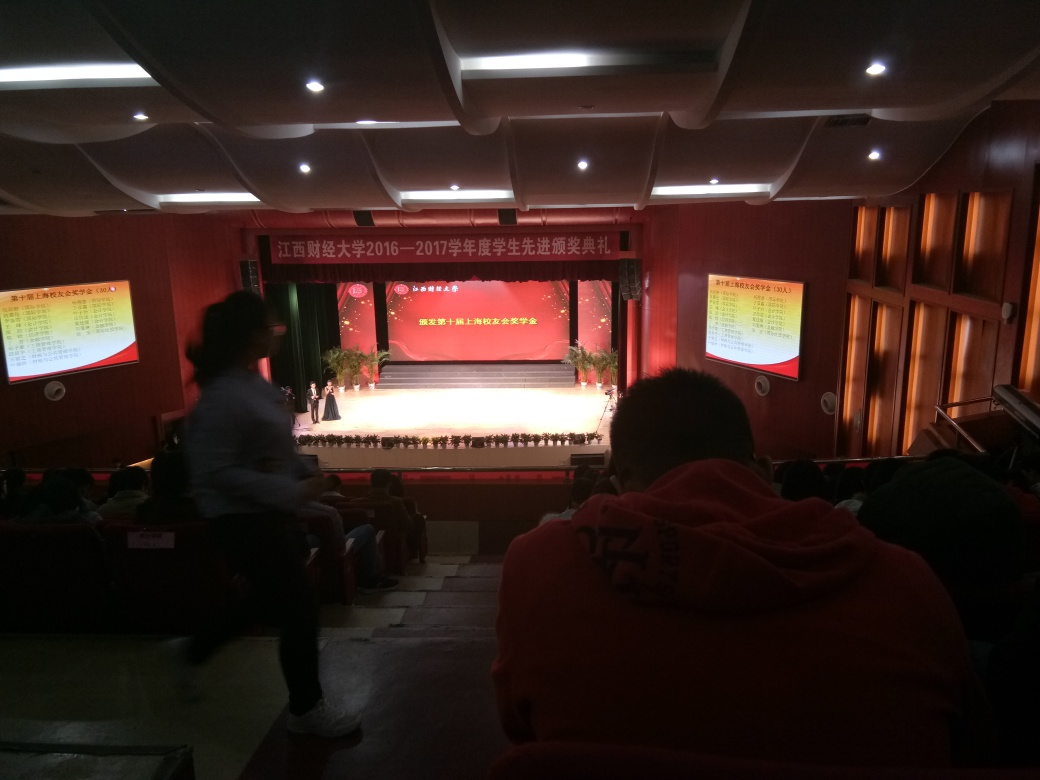What can you infer about the event from the banners and the stage setup? The banners on the left and right feature Chinese text, suggesting that the event is likely taking place in a Chinese-speaking region. Coupled with the organized rows of individuals on the stage and the formal dress code, it could be an educational or academic event, perhaps a graduation ceremony, scholarship announcement, or an academic year-end summary. 